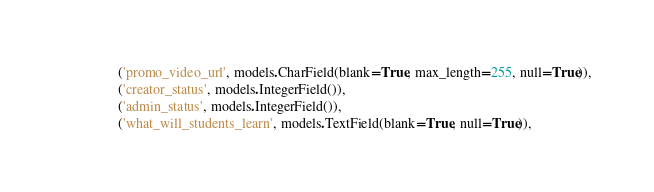Convert code to text. <code><loc_0><loc_0><loc_500><loc_500><_Python_>                ('promo_video_url', models.CharField(blank=True, max_length=255, null=True)),
                ('creator_status', models.IntegerField()),
                ('admin_status', models.IntegerField()),
                ('what_will_students_learn', models.TextField(blank=True, null=True)),</code> 